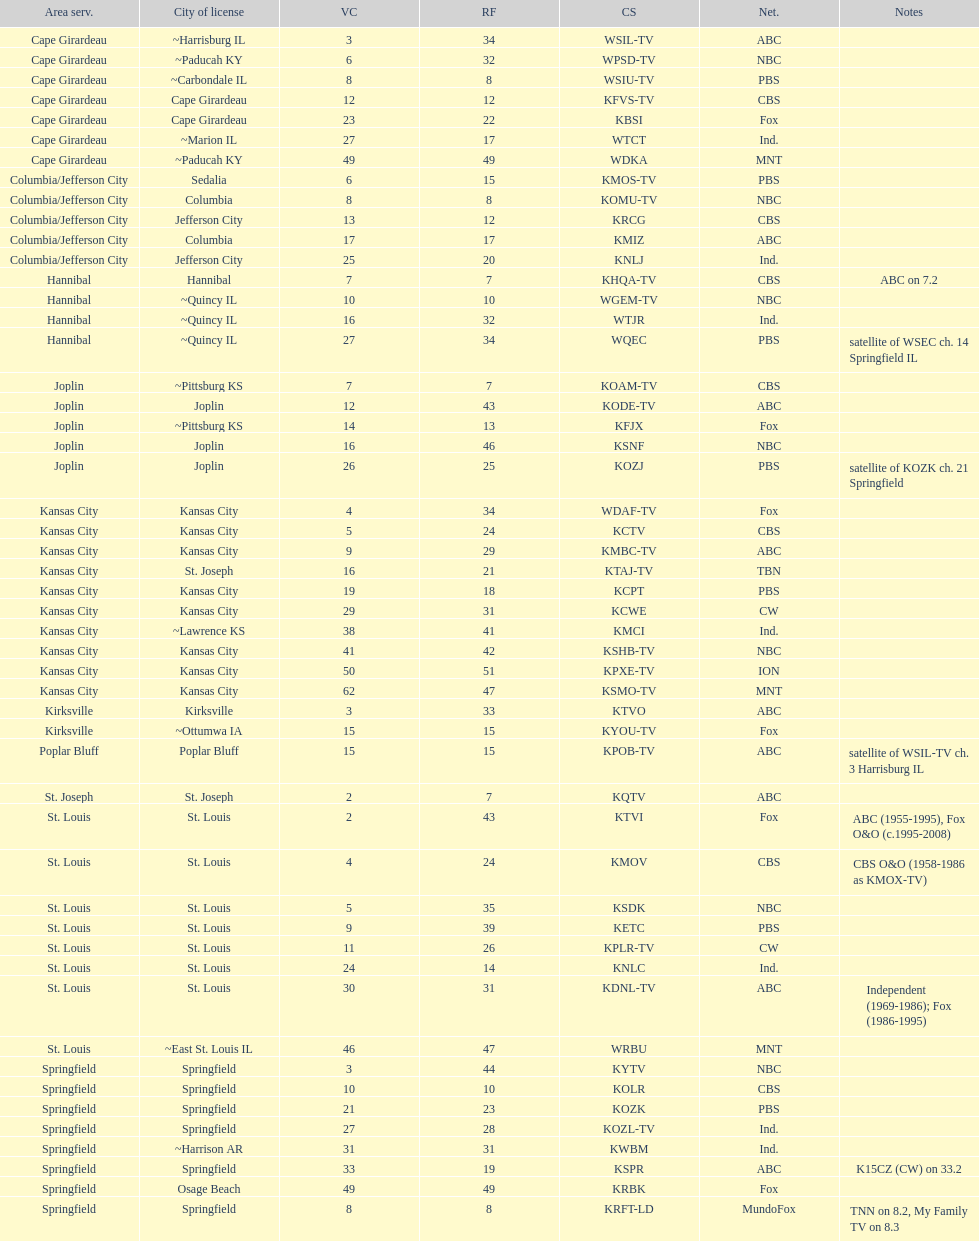How many television stations serve the cape girardeau area? 7. 